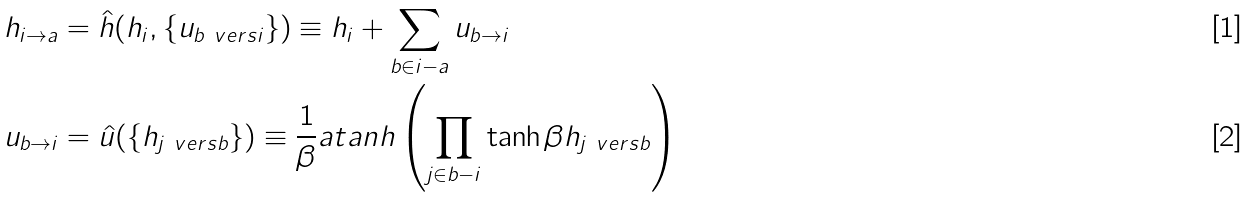<formula> <loc_0><loc_0><loc_500><loc_500>h _ { i \to a } & = \hat { h } ( h _ { i } , \{ u _ { b \ v e r s i } \} ) \equiv h _ { i } + \sum _ { b \in i - a } u _ { b \to i } \\ u _ { b \to i } & = \hat { u } ( \{ h _ { j \ v e r s b } \} ) \equiv \frac { 1 } { \beta } a t a n h \left ( \prod _ { j \in b - i } \tanh \beta h _ { j \ v e r s b } \right )</formula> 